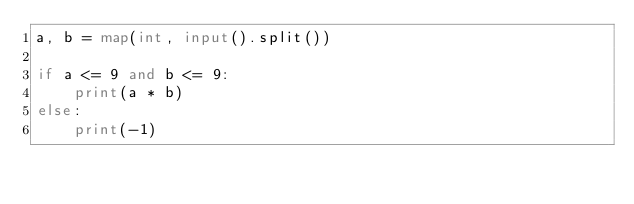<code> <loc_0><loc_0><loc_500><loc_500><_Python_>a, b = map(int, input().split())

if a <= 9 and b <= 9:
    print(a * b)
else:
    print(-1)
</code> 